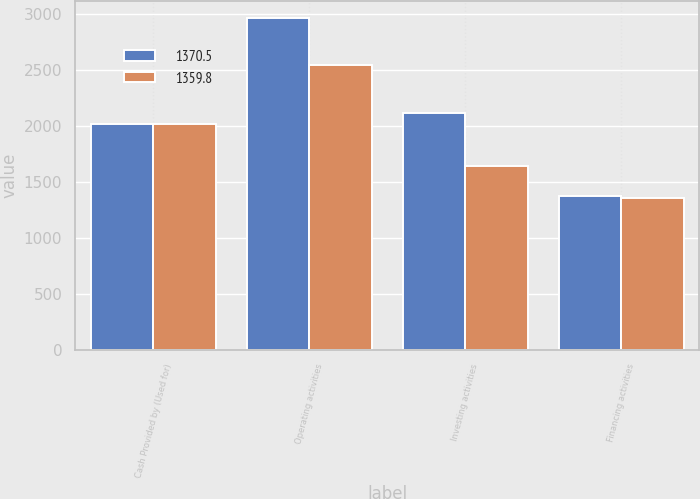Convert chart to OTSL. <chart><loc_0><loc_0><loc_500><loc_500><stacked_bar_chart><ecel><fcel>Cash Provided by (Used for)<fcel>Operating activities<fcel>Investing activities<fcel>Financing activities<nl><fcel>1370.5<fcel>2019<fcel>2969.9<fcel>2113.4<fcel>1370.5<nl><fcel>1359.8<fcel>2018<fcel>2547.2<fcel>1641.6<fcel>1359.8<nl></chart> 